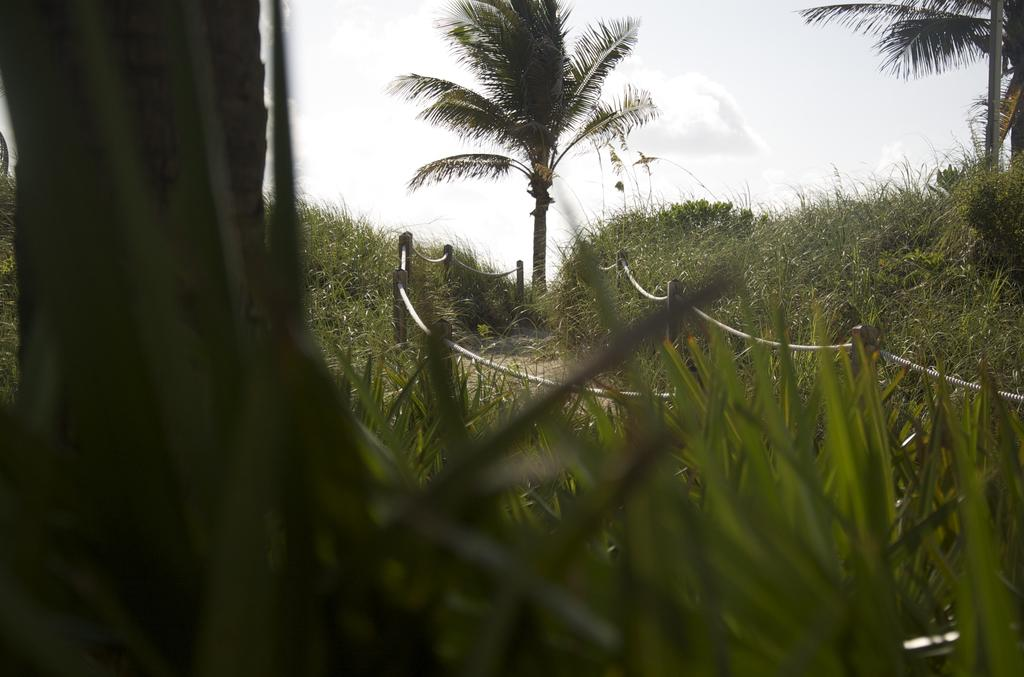What is located in the center of the image? There is fencing in the center of the image. What type of surface can be seen in the image? Ground is visible in the image. What type of vegetation is present in the image? Some plants and trees are present in the image. What is visible in the sky at the top of the image? Clouds are visible in the sky at the top of the image. What type of pan can be seen on the trees in the image? There is no pan present in the image, and trees do not have pans. 